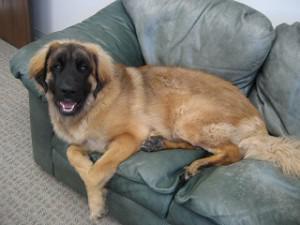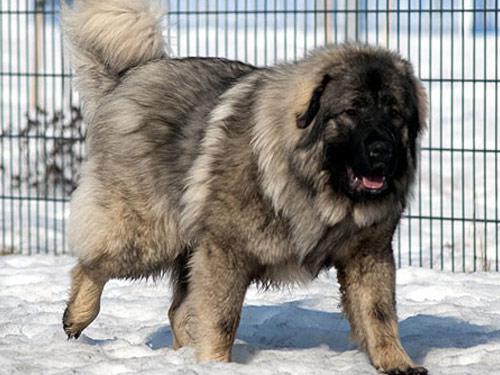The first image is the image on the left, the second image is the image on the right. For the images shown, is this caption "Two large dogs have black faces and their mouths open." true? Answer yes or no. Yes. The first image is the image on the left, the second image is the image on the right. Given the left and right images, does the statement "There is a woman with a large dog in the image on the left" hold true? Answer yes or no. No. 